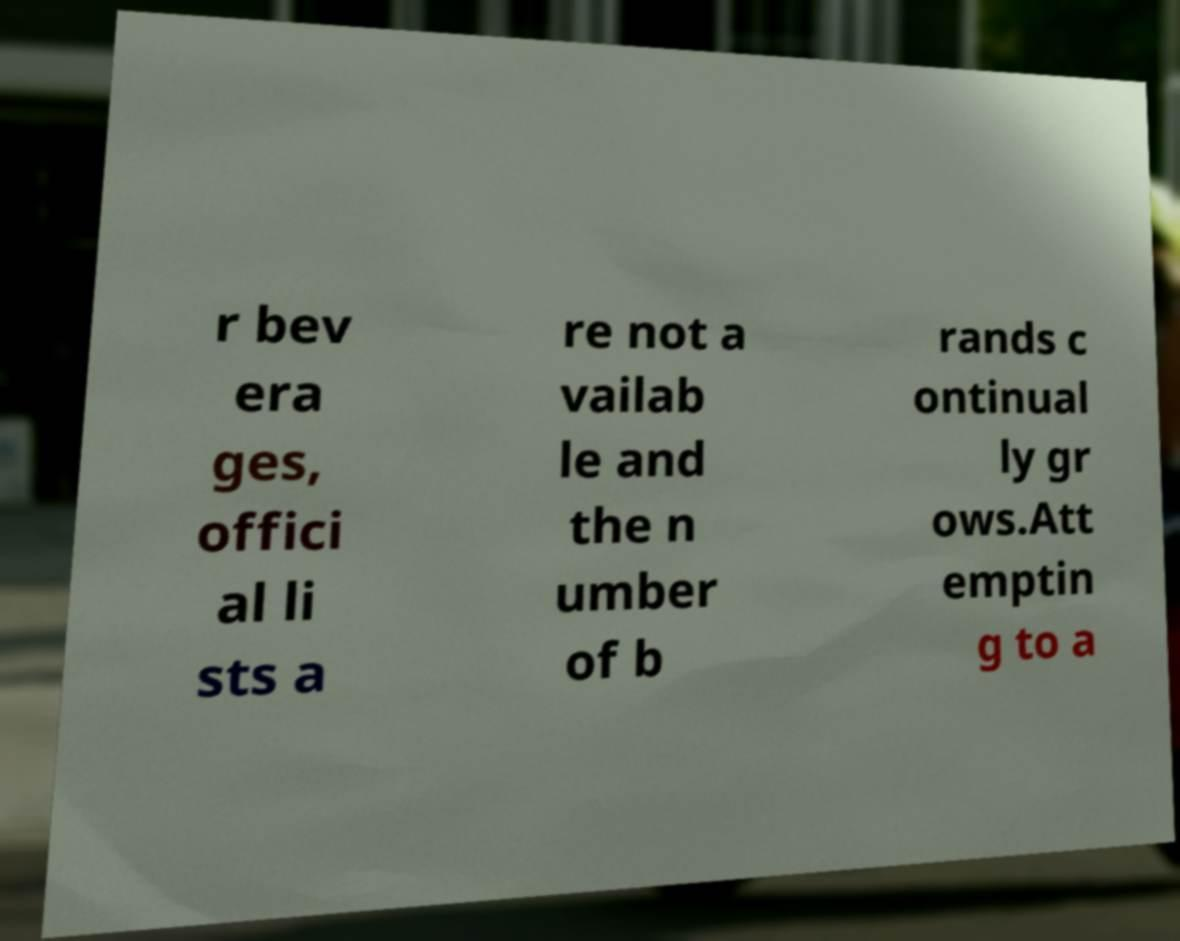Please read and relay the text visible in this image. What does it say? r bev era ges, offici al li sts a re not a vailab le and the n umber of b rands c ontinual ly gr ows.Att emptin g to a 